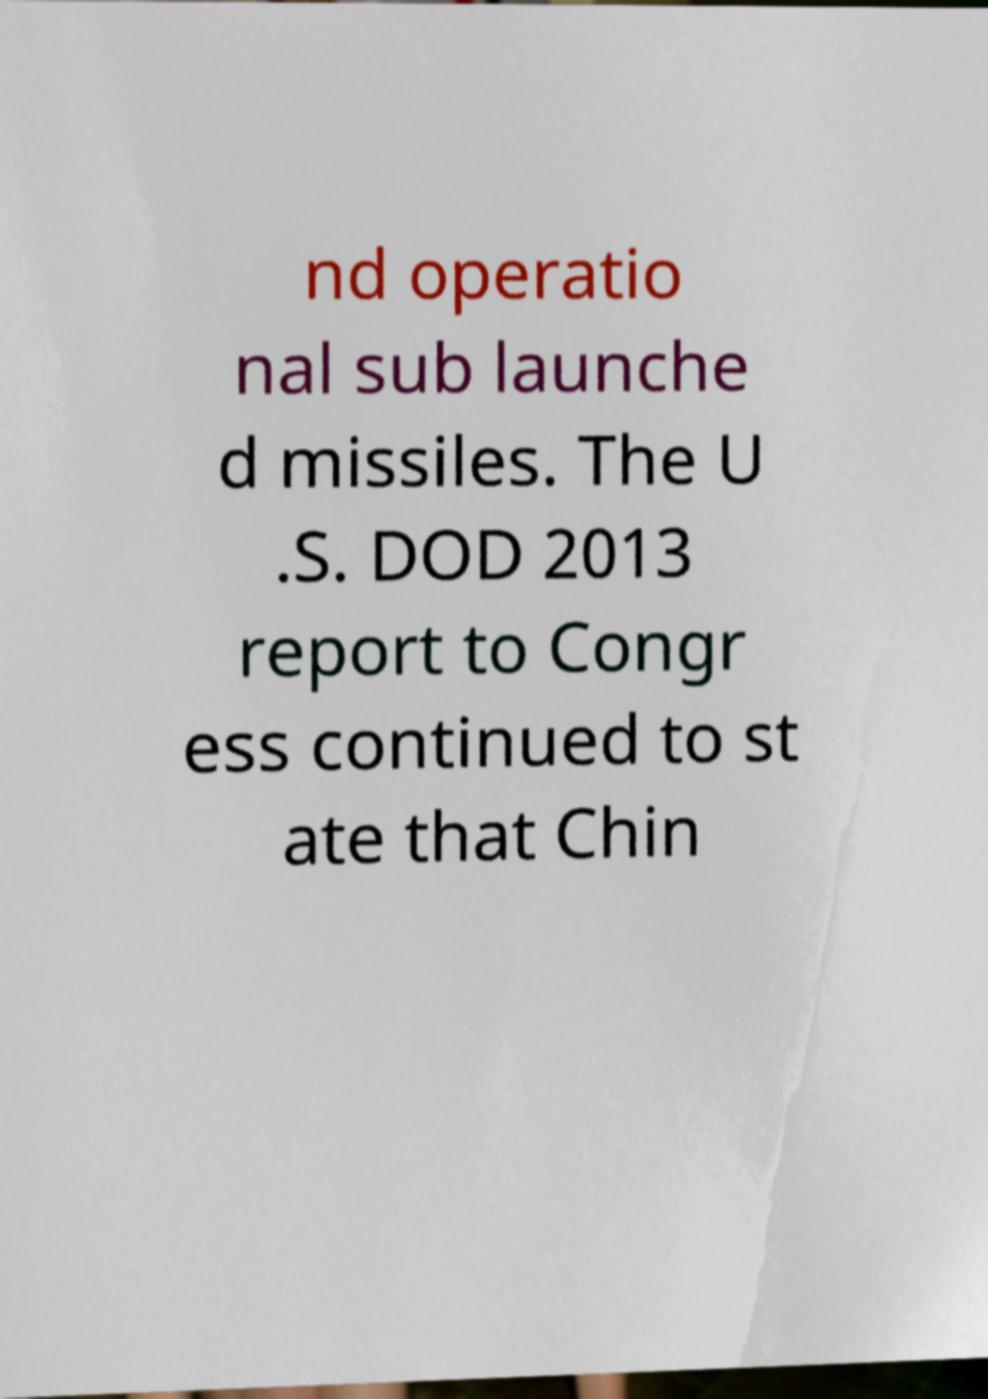Could you assist in decoding the text presented in this image and type it out clearly? nd operatio nal sub launche d missiles. The U .S. DOD 2013 report to Congr ess continued to st ate that Chin 